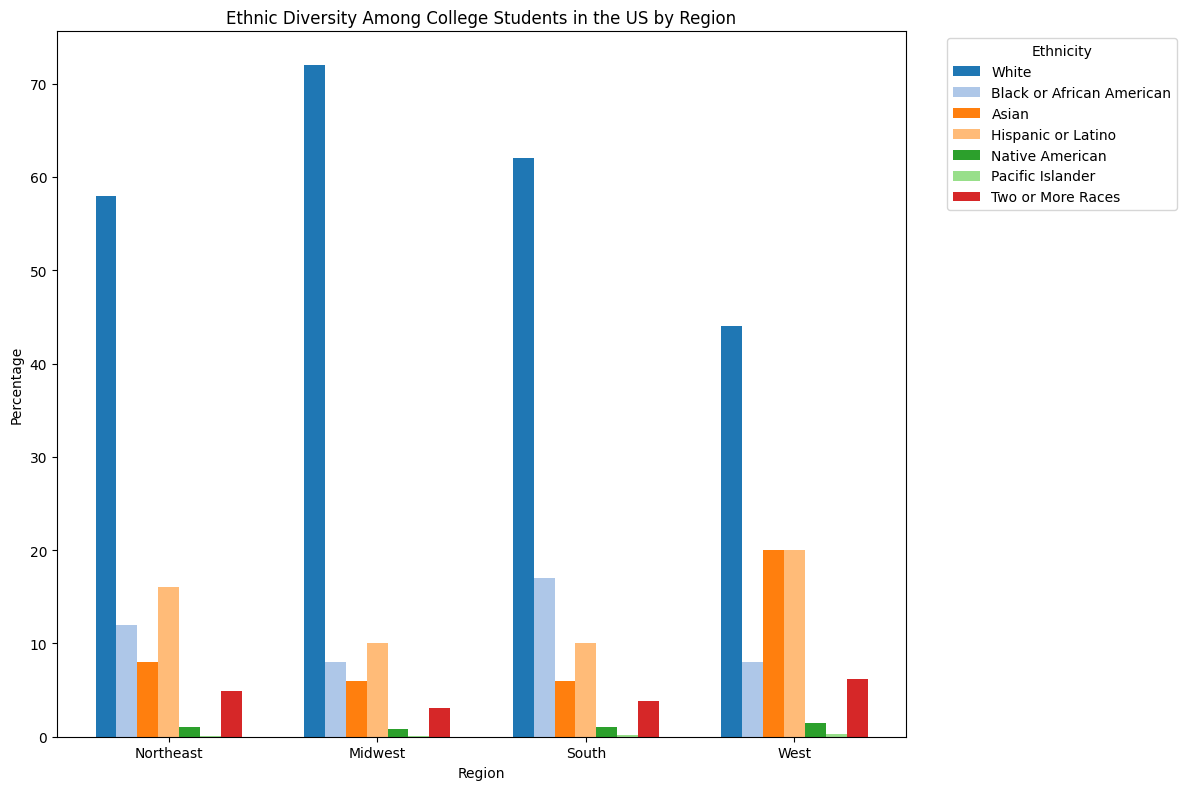Which region has the highest percentage of White students? By inspecting the bars representing White students in each region, the Midwest has the tallest bar, indicating the highest percentage.
Answer: Midwest Which ethnicity has the smallest representation in the South? By comparing the heights of all bars in the South, Pacific Islander has the smallest representation.
Answer: Pacific Islander What is the sum of the percentages of Black or African American students in the Northeast and South? From the bars, the percentage of Black or African American students is 12% in the Northeast and 17% in the South. Summing these gives 12 + 17 = 29%.
Answer: 29% Is the percentage of Asian students higher in the West or the Midwest? The bar representing Asian students is taller in the West compared to the Midwest.
Answer: West What is the average percentage of Hispanic or Latino students across all regions? The percentages for Hispanic or Latino students are 16% (Northeast), 10% (Midwest), 10% (South), and 20% (West). The average is calculated as (16 + 10 + 10 + 20) / 4 = 14%.
Answer: 14% Which region has the most diverse ethnic distribution, considering the spread of all categories? The West has a more balanced distribution across various categories, suggesting higher diversity.
Answer: West Is the percentage of Native American students in the Northeast higher than in the Midwest? The bar for Native American students is slightly taller in the Northeast compared to the Midwest.
Answer: Yes How does the percentage of students of Two or More Races in the West compare to the Northeast? The bar representing Two or More Races is taller in the West than in the Northeast.
Answer: Higher in the West What's the difference in the percentage of Asian students between the Northeast and the West? The percentages are 8% for the Northeast and 20% for the West. The difference is 20 - 8 = 12%.
Answer: 12% What is the combined percentage of Native American and Pacific Islander students in the Midwest? For the Midwest, Native American is 0.8% and Pacific Islander is 0.1%. Their combined percentage is 0.8 + 0.1 = 0.9%.
Answer: 0.9% 